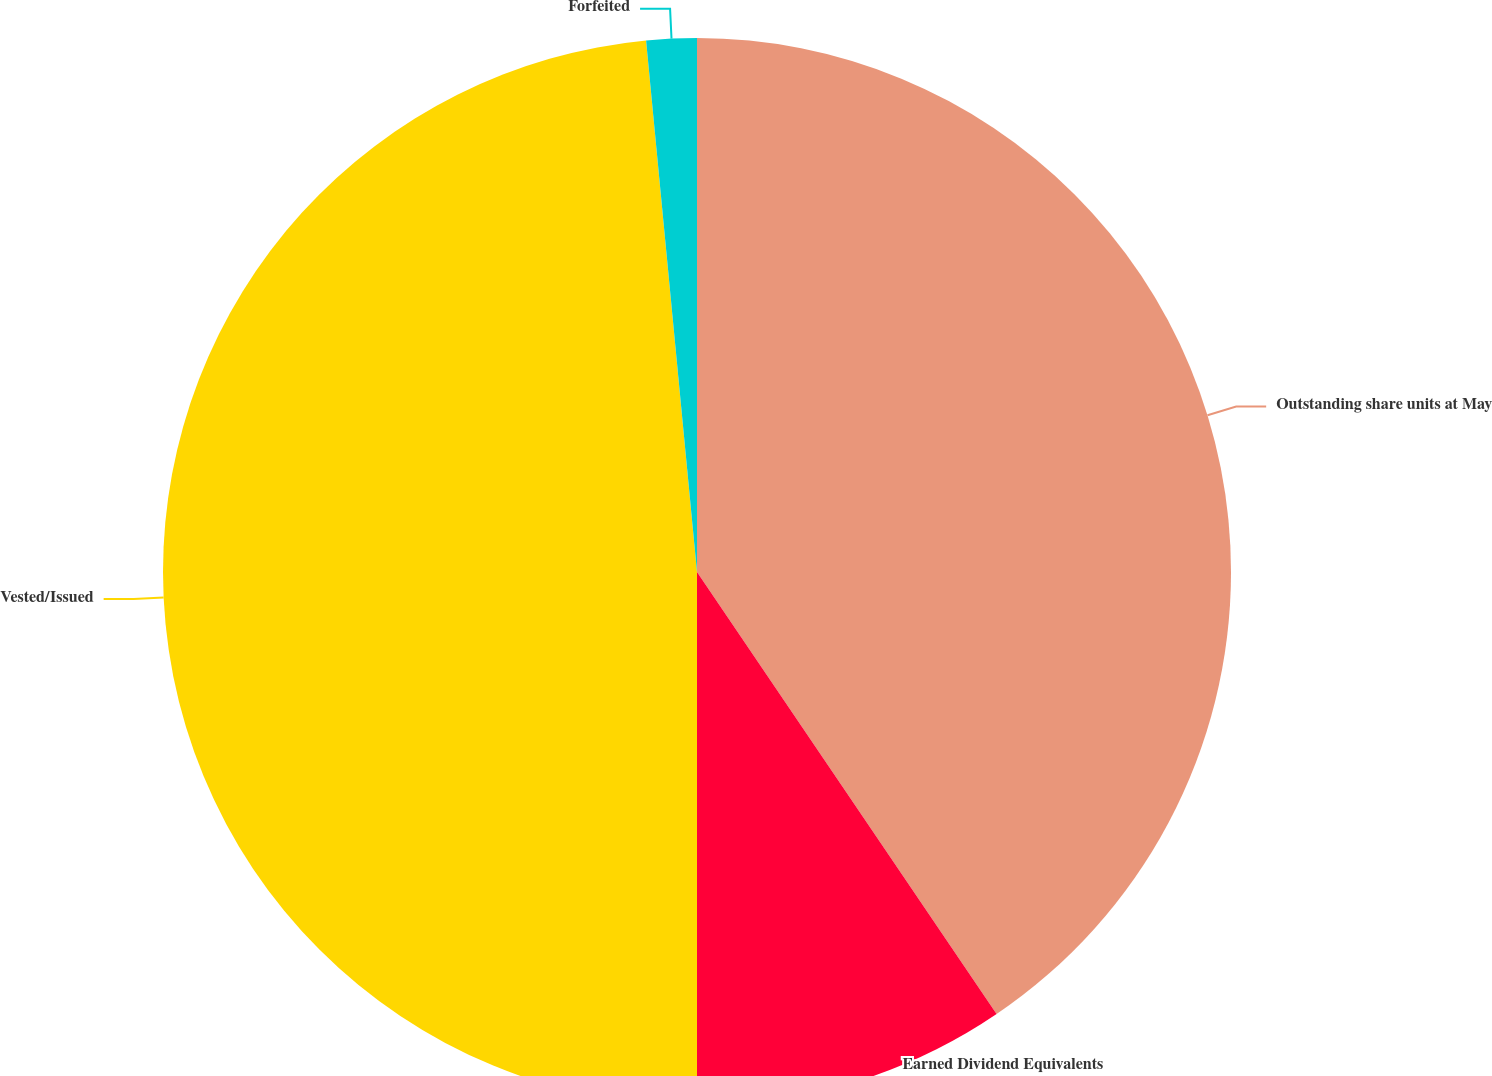Convert chart to OTSL. <chart><loc_0><loc_0><loc_500><loc_500><pie_chart><fcel>Outstanding share units at May<fcel>Earned Dividend Equivalents<fcel>Vested/Issued<fcel>Forfeited<nl><fcel>40.52%<fcel>9.48%<fcel>48.48%<fcel>1.52%<nl></chart> 